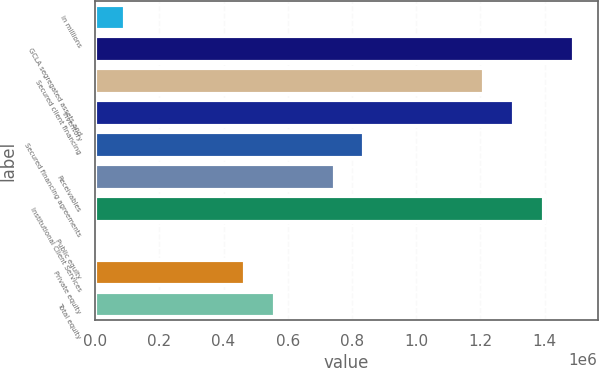<chart> <loc_0><loc_0><loc_500><loc_500><bar_chart><fcel>in millions<fcel>GCLA segregated assets and<fcel>Secured client financing<fcel>Inventory<fcel>Secured financing agreements<fcel>Receivables<fcel>Institutional Client Services<fcel>Public equity<fcel>Private equity<fcel>Total equity<nl><fcel>94480.1<fcel>1.49001e+06<fcel>1.2109e+06<fcel>1.30394e+06<fcel>838761<fcel>745726<fcel>1.39697e+06<fcel>1445<fcel>466620<fcel>559656<nl></chart> 